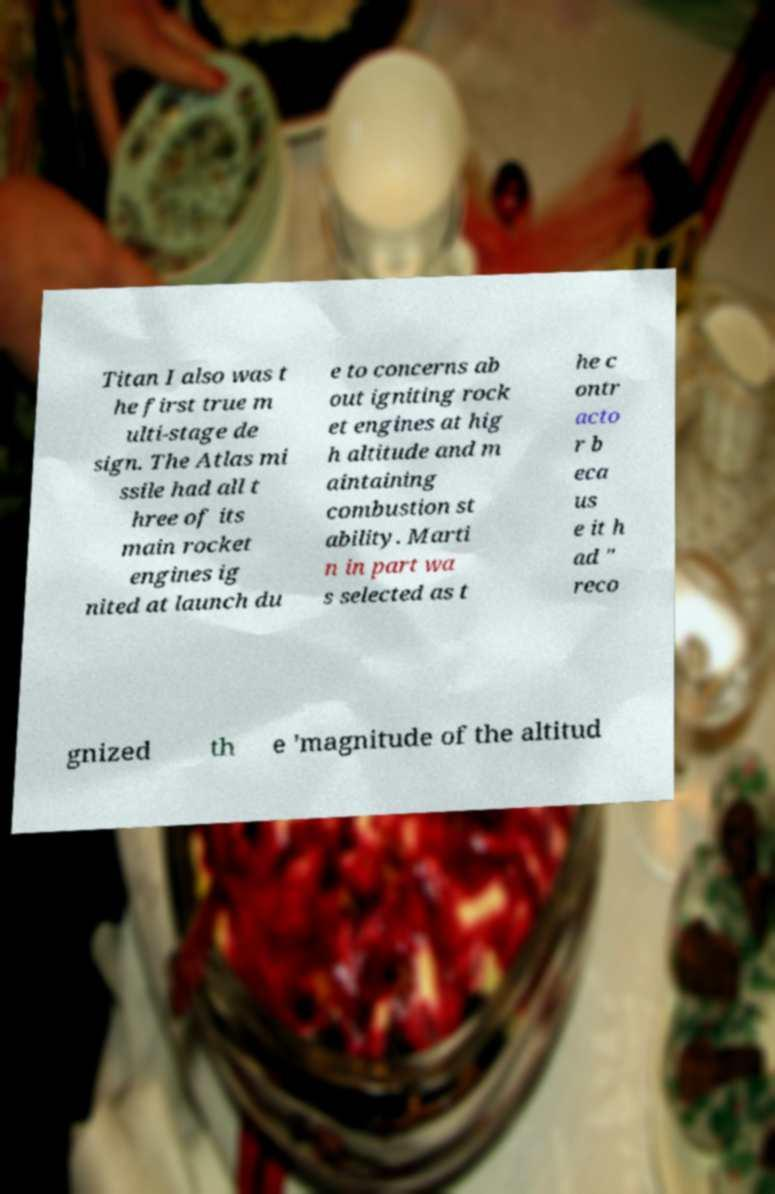For documentation purposes, I need the text within this image transcribed. Could you provide that? Titan I also was t he first true m ulti-stage de sign. The Atlas mi ssile had all t hree of its main rocket engines ig nited at launch du e to concerns ab out igniting rock et engines at hig h altitude and m aintaining combustion st ability. Marti n in part wa s selected as t he c ontr acto r b eca us e it h ad " reco gnized th e 'magnitude of the altitud 